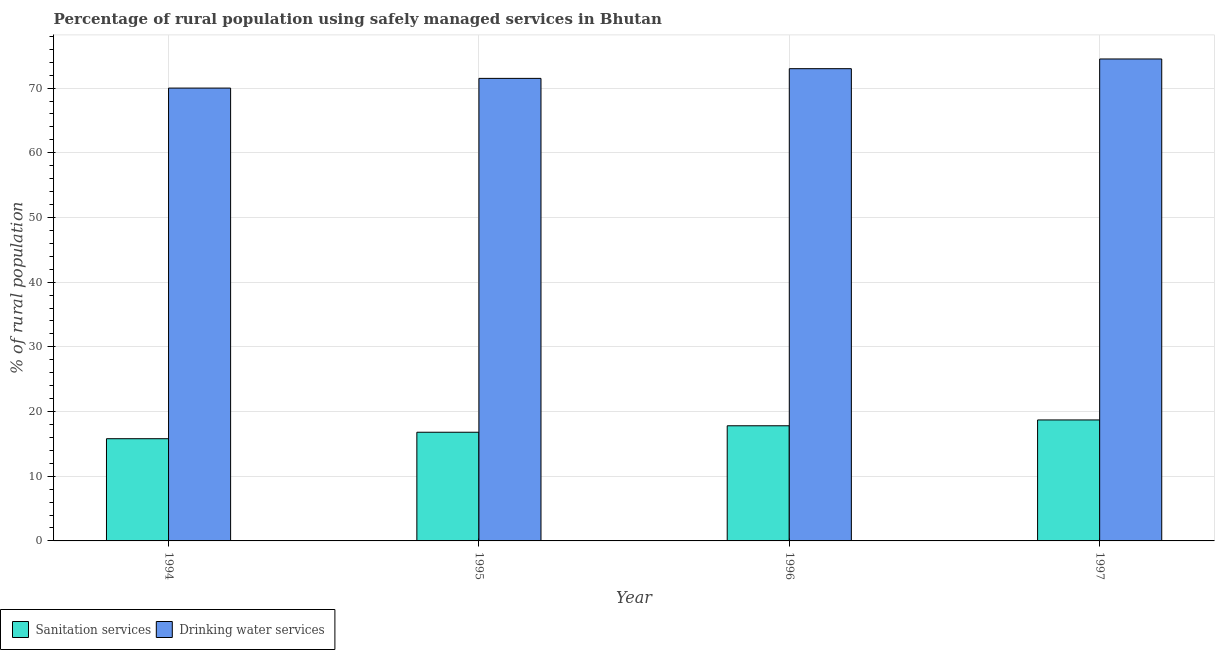How many bars are there on the 3rd tick from the right?
Your answer should be compact. 2. In how many cases, is the number of bars for a given year not equal to the number of legend labels?
Offer a very short reply. 0. What is the percentage of rural population who used drinking water services in 1997?
Ensure brevity in your answer.  74.5. Across all years, what is the minimum percentage of rural population who used sanitation services?
Give a very brief answer. 15.8. In which year was the percentage of rural population who used drinking water services maximum?
Your response must be concise. 1997. In which year was the percentage of rural population who used sanitation services minimum?
Give a very brief answer. 1994. What is the total percentage of rural population who used sanitation services in the graph?
Provide a succinct answer. 69.1. What is the average percentage of rural population who used sanitation services per year?
Keep it short and to the point. 17.28. In the year 1997, what is the difference between the percentage of rural population who used drinking water services and percentage of rural population who used sanitation services?
Make the answer very short. 0. What is the ratio of the percentage of rural population who used drinking water services in 1994 to that in 1997?
Provide a succinct answer. 0.94. What is the difference between the highest and the second highest percentage of rural population who used sanitation services?
Offer a very short reply. 0.9. What is the difference between the highest and the lowest percentage of rural population who used sanitation services?
Your answer should be very brief. 2.9. In how many years, is the percentage of rural population who used drinking water services greater than the average percentage of rural population who used drinking water services taken over all years?
Your answer should be compact. 2. Is the sum of the percentage of rural population who used sanitation services in 1994 and 1995 greater than the maximum percentage of rural population who used drinking water services across all years?
Offer a very short reply. Yes. What does the 1st bar from the left in 1995 represents?
Offer a terse response. Sanitation services. What does the 1st bar from the right in 1995 represents?
Provide a succinct answer. Drinking water services. How many years are there in the graph?
Your response must be concise. 4. What is the difference between two consecutive major ticks on the Y-axis?
Your response must be concise. 10. Are the values on the major ticks of Y-axis written in scientific E-notation?
Offer a terse response. No. Where does the legend appear in the graph?
Your answer should be very brief. Bottom left. What is the title of the graph?
Ensure brevity in your answer.  Percentage of rural population using safely managed services in Bhutan. Does "Arms imports" appear as one of the legend labels in the graph?
Offer a very short reply. No. What is the label or title of the X-axis?
Offer a terse response. Year. What is the label or title of the Y-axis?
Your answer should be very brief. % of rural population. What is the % of rural population of Drinking water services in 1995?
Your response must be concise. 71.5. What is the % of rural population in Drinking water services in 1997?
Provide a succinct answer. 74.5. Across all years, what is the maximum % of rural population in Drinking water services?
Your answer should be very brief. 74.5. What is the total % of rural population of Sanitation services in the graph?
Your response must be concise. 69.1. What is the total % of rural population in Drinking water services in the graph?
Give a very brief answer. 289. What is the difference between the % of rural population of Drinking water services in 1994 and that in 1995?
Offer a very short reply. -1.5. What is the difference between the % of rural population of Sanitation services in 1994 and that in 1997?
Your answer should be very brief. -2.9. What is the difference between the % of rural population of Sanitation services in 1995 and that in 1996?
Offer a terse response. -1. What is the difference between the % of rural population of Sanitation services in 1994 and the % of rural population of Drinking water services in 1995?
Ensure brevity in your answer.  -55.7. What is the difference between the % of rural population of Sanitation services in 1994 and the % of rural population of Drinking water services in 1996?
Keep it short and to the point. -57.2. What is the difference between the % of rural population of Sanitation services in 1994 and the % of rural population of Drinking water services in 1997?
Provide a succinct answer. -58.7. What is the difference between the % of rural population in Sanitation services in 1995 and the % of rural population in Drinking water services in 1996?
Provide a short and direct response. -56.2. What is the difference between the % of rural population of Sanitation services in 1995 and the % of rural population of Drinking water services in 1997?
Give a very brief answer. -57.7. What is the difference between the % of rural population of Sanitation services in 1996 and the % of rural population of Drinking water services in 1997?
Make the answer very short. -56.7. What is the average % of rural population of Sanitation services per year?
Offer a terse response. 17.27. What is the average % of rural population of Drinking water services per year?
Your response must be concise. 72.25. In the year 1994, what is the difference between the % of rural population of Sanitation services and % of rural population of Drinking water services?
Offer a very short reply. -54.2. In the year 1995, what is the difference between the % of rural population of Sanitation services and % of rural population of Drinking water services?
Your response must be concise. -54.7. In the year 1996, what is the difference between the % of rural population of Sanitation services and % of rural population of Drinking water services?
Keep it short and to the point. -55.2. In the year 1997, what is the difference between the % of rural population in Sanitation services and % of rural population in Drinking water services?
Make the answer very short. -55.8. What is the ratio of the % of rural population of Sanitation services in 1994 to that in 1995?
Offer a terse response. 0.94. What is the ratio of the % of rural population in Drinking water services in 1994 to that in 1995?
Provide a succinct answer. 0.98. What is the ratio of the % of rural population in Sanitation services in 1994 to that in 1996?
Your answer should be compact. 0.89. What is the ratio of the % of rural population in Drinking water services in 1994 to that in 1996?
Ensure brevity in your answer.  0.96. What is the ratio of the % of rural population in Sanitation services in 1994 to that in 1997?
Ensure brevity in your answer.  0.84. What is the ratio of the % of rural population in Drinking water services in 1994 to that in 1997?
Provide a short and direct response. 0.94. What is the ratio of the % of rural population of Sanitation services in 1995 to that in 1996?
Make the answer very short. 0.94. What is the ratio of the % of rural population in Drinking water services in 1995 to that in 1996?
Provide a short and direct response. 0.98. What is the ratio of the % of rural population of Sanitation services in 1995 to that in 1997?
Your response must be concise. 0.9. What is the ratio of the % of rural population of Drinking water services in 1995 to that in 1997?
Keep it short and to the point. 0.96. What is the ratio of the % of rural population of Sanitation services in 1996 to that in 1997?
Provide a short and direct response. 0.95. What is the ratio of the % of rural population in Drinking water services in 1996 to that in 1997?
Offer a terse response. 0.98. 